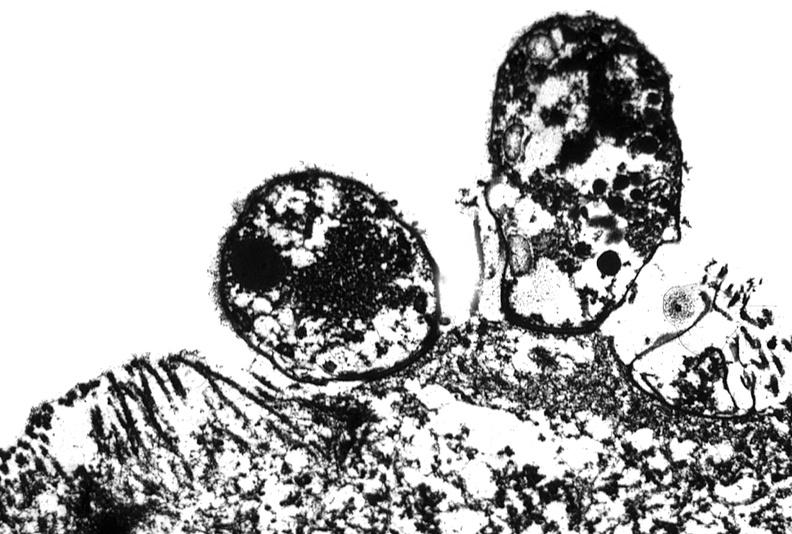s gastrointestinal present?
Answer the question using a single word or phrase. Yes 